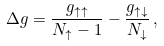Convert formula to latex. <formula><loc_0><loc_0><loc_500><loc_500>\Delta g = \frac { g _ { \uparrow \uparrow } } { N _ { \uparrow } - 1 } - \frac { g _ { \uparrow \downarrow } } { N _ { \downarrow } } \, ,</formula> 